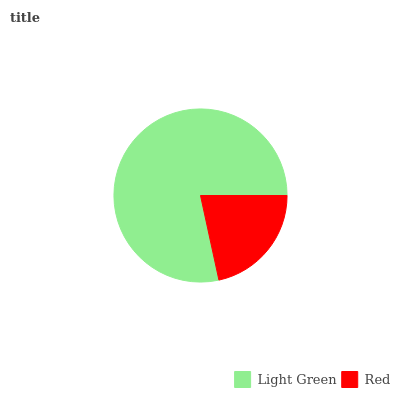Is Red the minimum?
Answer yes or no. Yes. Is Light Green the maximum?
Answer yes or no. Yes. Is Red the maximum?
Answer yes or no. No. Is Light Green greater than Red?
Answer yes or no. Yes. Is Red less than Light Green?
Answer yes or no. Yes. Is Red greater than Light Green?
Answer yes or no. No. Is Light Green less than Red?
Answer yes or no. No. Is Light Green the high median?
Answer yes or no. Yes. Is Red the low median?
Answer yes or no. Yes. Is Red the high median?
Answer yes or no. No. Is Light Green the low median?
Answer yes or no. No. 